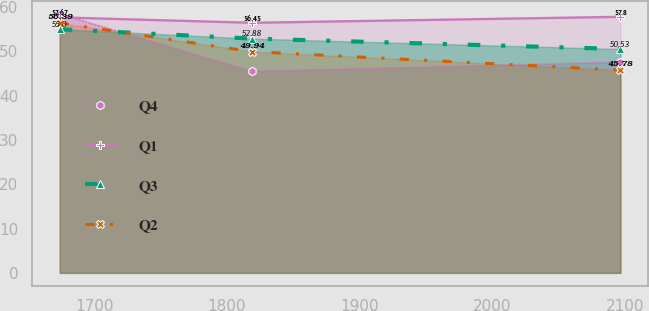<chart> <loc_0><loc_0><loc_500><loc_500><line_chart><ecel><fcel>Q4<fcel>Q1<fcel>Q3<fcel>Q2<nl><fcel>1674.06<fcel>58.45<fcel>57.67<fcel>55<fcel>56.39<nl><fcel>1819.02<fcel>45.51<fcel>56.45<fcel>52.88<fcel>49.94<nl><fcel>2096.63<fcel>47.6<fcel>57.8<fcel>50.53<fcel>45.78<nl></chart> 